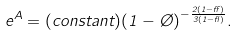Convert formula to latex. <formula><loc_0><loc_0><loc_500><loc_500>e ^ { A } = ( c o n s t a n t ) ( 1 - \chi ) ^ { - \frac { 2 ( 1 - \alpha ) } { 3 ( 1 - \gamma ) } } .</formula> 